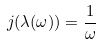<formula> <loc_0><loc_0><loc_500><loc_500>j ( \lambda ( \omega ) ) = \frac { 1 } { \omega }</formula> 